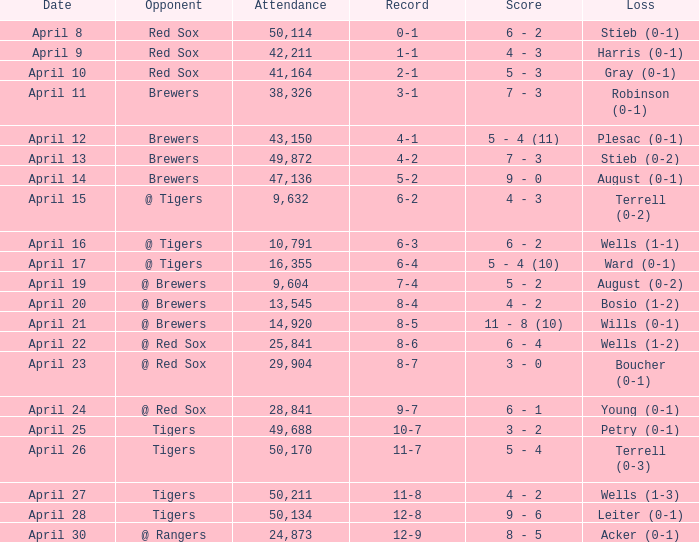Which opponent has a loss of wells (1-3)? Tigers. 